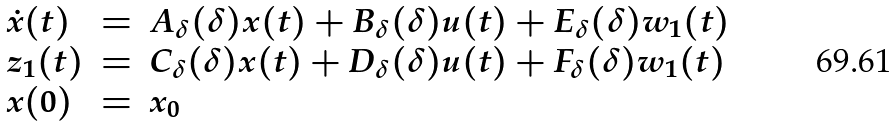Convert formula to latex. <formula><loc_0><loc_0><loc_500><loc_500>\begin{array} { l c l } \dot { x } ( t ) & = & A _ { \delta } ( \delta ) x ( t ) + B _ { \delta } ( \delta ) u ( t ) + E _ { \delta } ( \delta ) w _ { 1 } ( t ) \\ z _ { 1 } ( t ) & = & C _ { \delta } ( \delta ) x ( t ) + D _ { \delta } ( \delta ) u ( t ) + F _ { \delta } ( \delta ) w _ { 1 } ( t ) \\ x ( 0 ) & = & x _ { 0 } \end{array}</formula> 